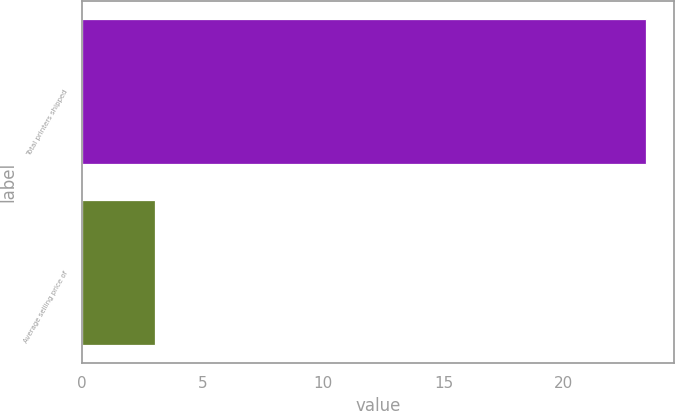Convert chart. <chart><loc_0><loc_0><loc_500><loc_500><bar_chart><fcel>Total printers shipped<fcel>Average selling price of<nl><fcel>23.4<fcel>3<nl></chart> 